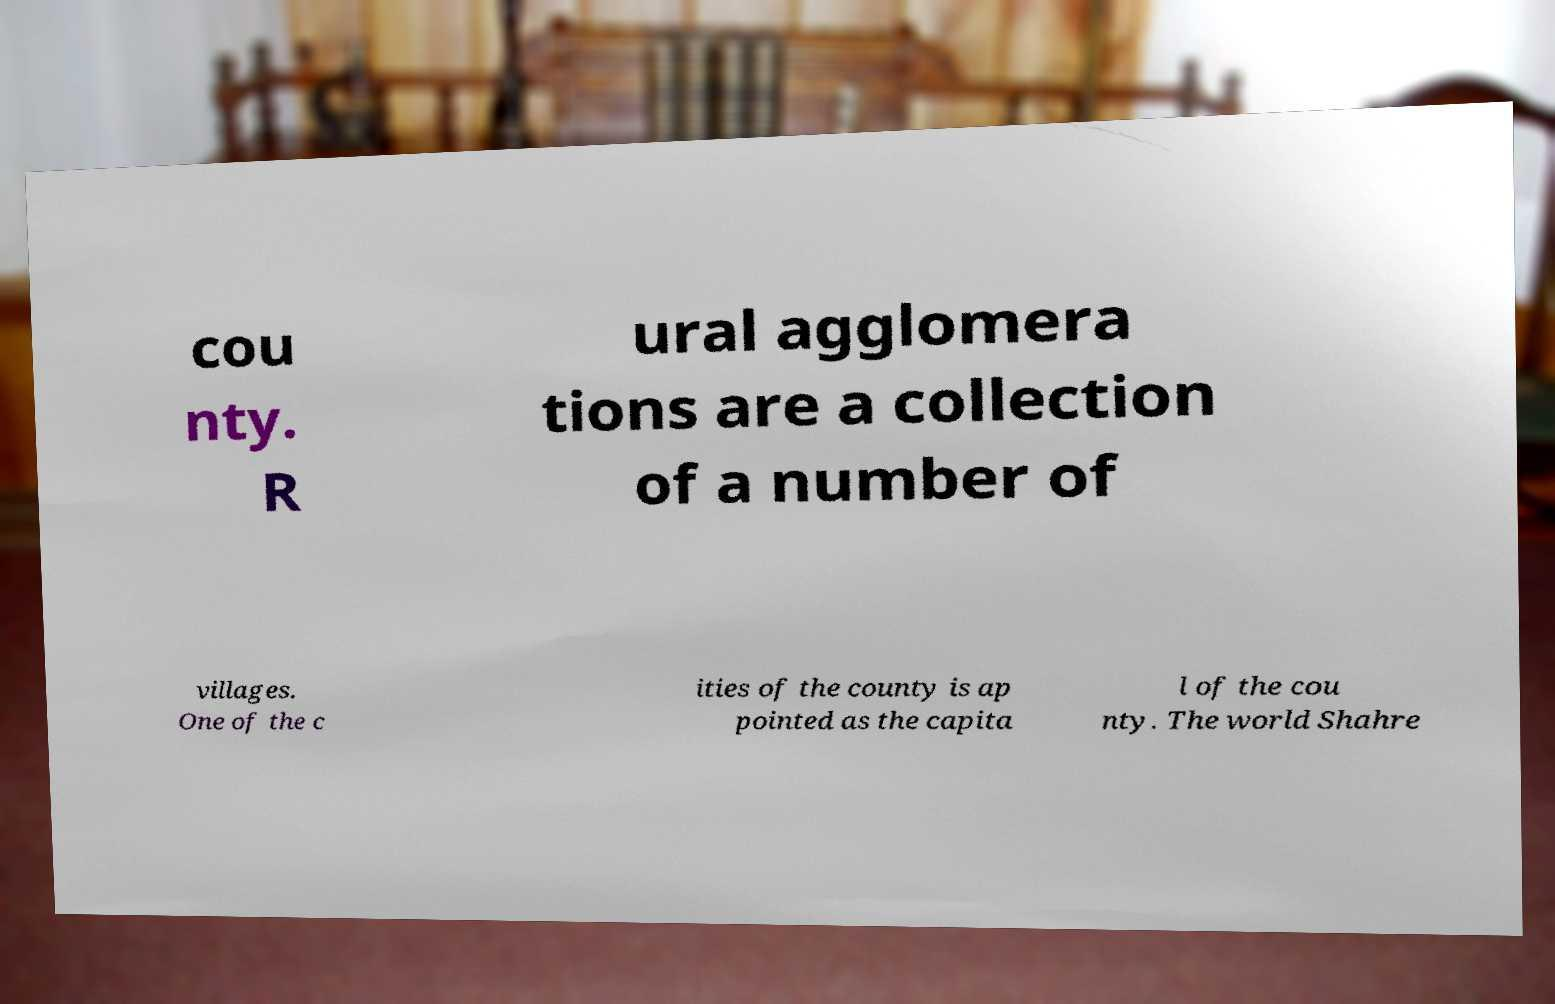Please identify and transcribe the text found in this image. cou nty. R ural agglomera tions are a collection of a number of villages. One of the c ities of the county is ap pointed as the capita l of the cou nty. The world Shahre 